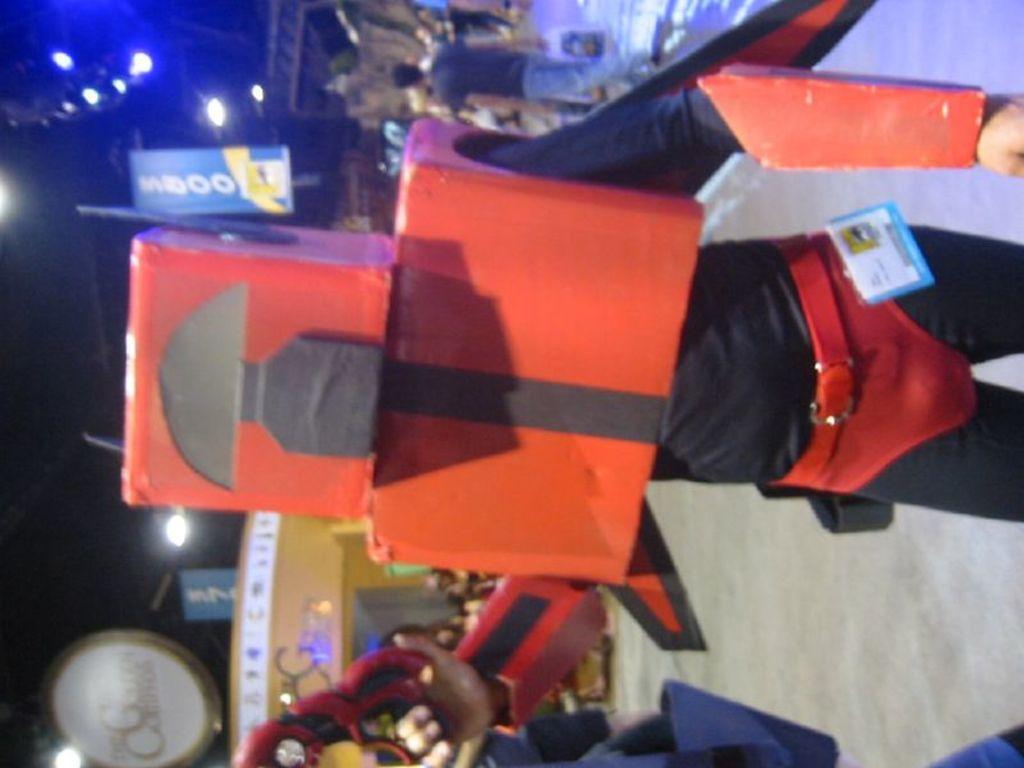Please provide a concise description of this image. In this picture we can see a person wore a costume and at the back of this person we can see a group of people on the ground, banners, lights, some objects and in the background it is dark. 